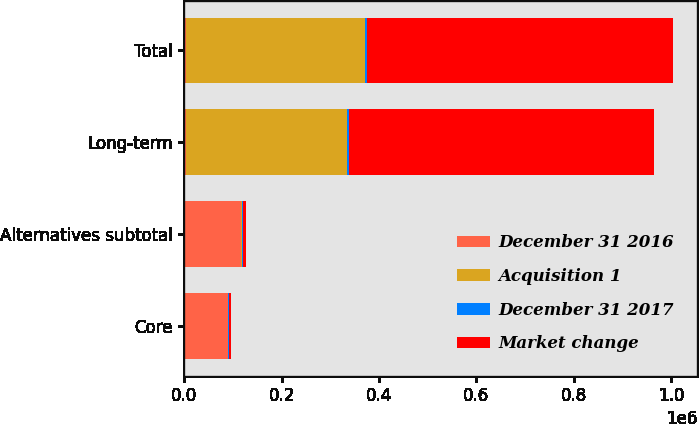<chart> <loc_0><loc_0><loc_500><loc_500><stacked_bar_chart><ecel><fcel>Core<fcel>Alternatives subtotal<fcel>Long-term<fcel>Total<nl><fcel>December 31 2016<fcel>88630<fcel>116938<fcel>4344.5<fcel>4344.5<nl><fcel>Acquisition 1<fcel>780<fcel>977<fcel>330240<fcel>367254<nl><fcel>December 31 2017<fcel>3264<fcel>3264<fcel>3264<fcel>3264<nl><fcel>Market change<fcel>3438<fcel>5251<fcel>627867<fcel>628901<nl></chart> 